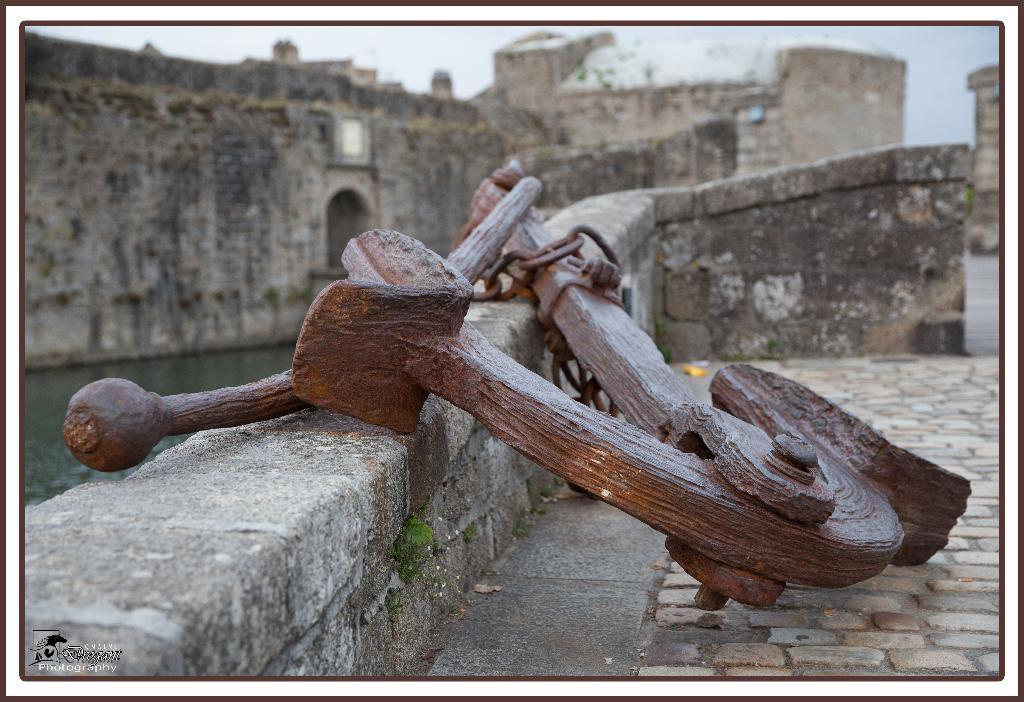What is the main structure in the image? There is a monument in the image. What else can be seen in the image besides the monument? There is an object, a lake, the sky, and boards visible in the image. What is the body of water in the image? There is a lake in the image. What is visible in the sky in the image? The sky is visible in the image. How many girls are wearing scarves while measuring the monument in the image? There are no girls, scarves, or measuring activities present in the image. 